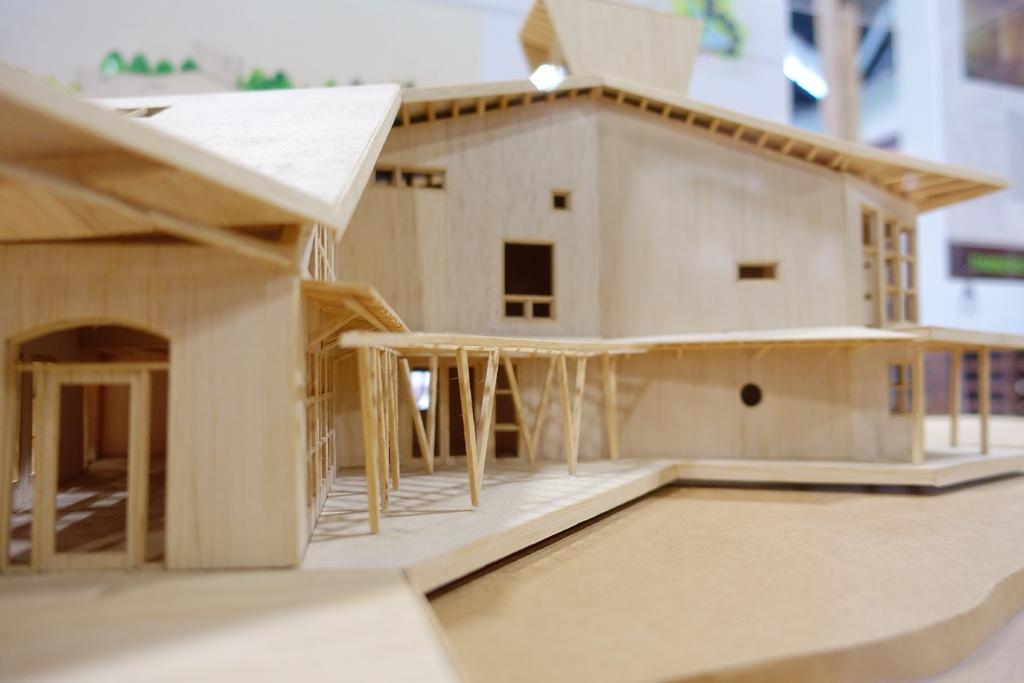What type of structure is depicted in the image? There is a miniature building in the image. What can be seen in the background of the image? There is a wall in the background of the image. What type of comb is used to style the miniature building in the image? There is no comb present in the image, and the miniature building is not a living being that requires styling. 